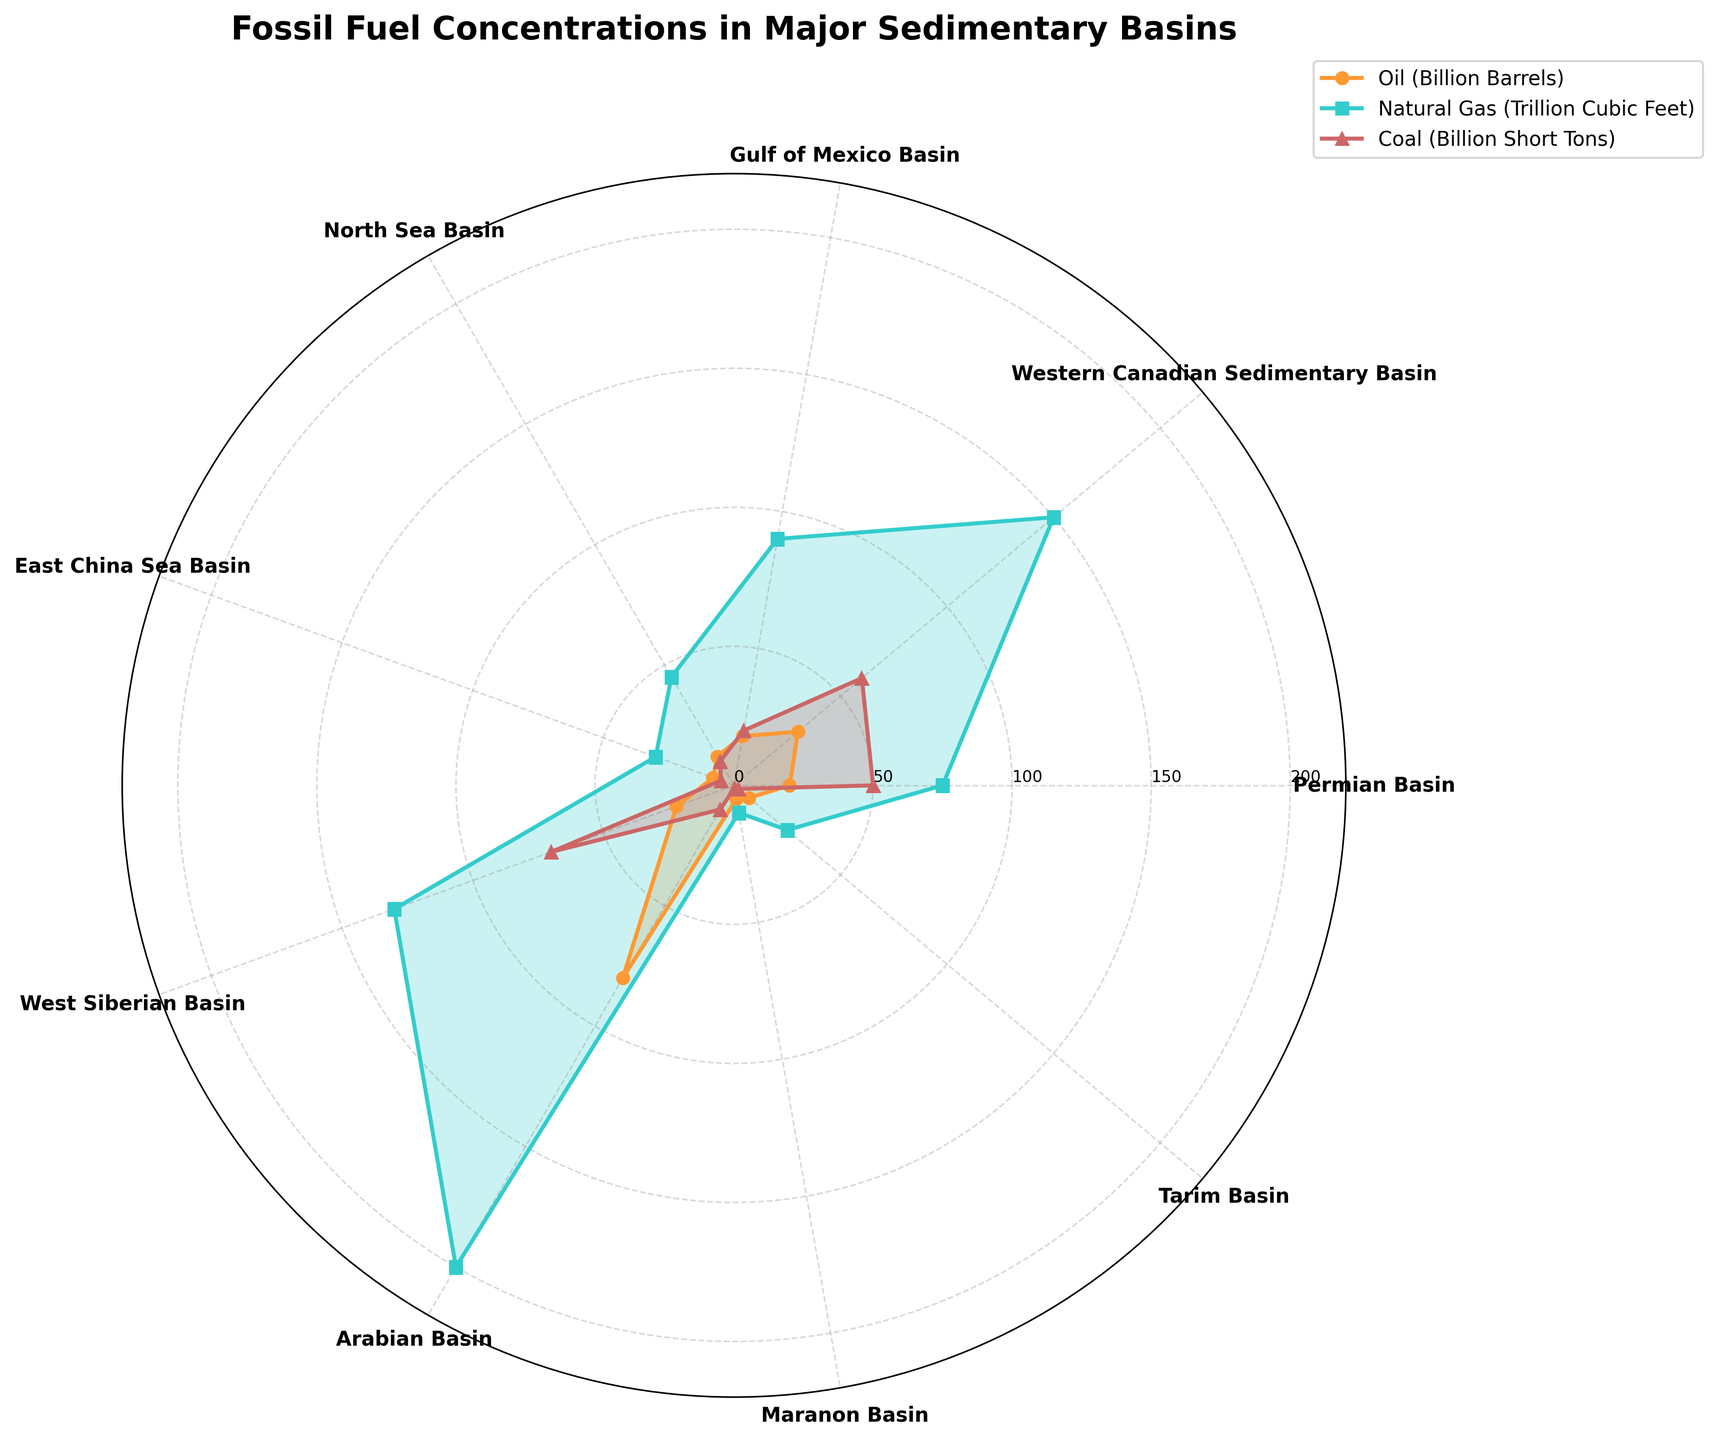What is the title of the polar chart? The title of the chart is prominently displayed at the top and reads "Fossil Fuel Concentrations in Major Sedimentary Basins".
Answer: Fossil Fuel Concentrations in Major Sedimentary Basins What are the labels for the three types of fossil fuels represented in the polar chart? The labels for the three types of fossil fuels can be found in the legend on the right side of the chart. They are "Oil (Billion Barrels)", "Natural Gas (Trillion Cubic Feet)", and "Coal (Billion Short Tons)".
Answer: Oil (Billion Barrels), Natural Gas (Trillion Cubic Feet), Coal (Billion Short Tons) Which sedimentary basin shows the highest concentration of natural gas? By finding the peak of the blue (Natural Gas) line on the chart, we can observe that the Arabian Basin has the highest concentration of natural gas, indicated by the highest point on the blue line.
Answer: Arabian Basin Of the basins listed, which two have the least concentration of coal, and how much coal do they contain collectively? The basins with the lowest concentration of coal are the Maranon Basin (1 Billion Short Ton) and the Tarim Basin (2 Billion Short Tons). Summing these values: 1 + 2 = 3 Billion Short Tons.
Answer: Maranon Basin and Tarim Basin; 3 Billion Short Tons Compare the concentrations of oil and coal in the Western Canadian Sedimentary Basin. Which is higher, and by what amount? To compare, we look at the heights of the orange (Oil) and red (Coal) lines for the Western Canadian Sedimentary Basin. Oil is at 30 Billion Barrels, and coal is at 60 Billion Short Tons. The difference is 60 - 30 = 30 units (in their respective units, but for this comparison, we use the same numerical value of 30).
Answer: Coal is higher by 30 units What is the total concentration of all three fossil fuels in the Permian Basin? By summing the values of the three fossil fuels in the Permian Basin: Oil (20 Billion Barrels) + Natural Gas (75 Trillion Cubic Feet) + Coal (50 Billion Short Tons), we get the total concentration. 20 + 75 + 50 = 145 units.
Answer: 145 units Which basin has the second lowest concentration of oil? Observing the orange (Oil) line for the basin with the second smallest peak, we find that the Tarim Basin has the second lowest concentration of oil, which is 7 Billion Barrels.
Answer: Tarim Basin How does the concentration of oil in the North Sea Basin compare to its concentration of natural gas? For the North Sea Basin, the orange (Oil) line is at 12 Billion Barrels, and the blue (Natural Gas) line is at 45 Trillion Cubic Feet. Natural Gas is higher: 45 - 12 = 33 units more.
Answer: Natural Gas is higher by 33 units What is the average concentration of coal across all basins? First, we sum the coal concentrations across all basins: 50 + 60 + 20 + 10 + 5 + 70 + 10 + 1 + 2 = 228. Then we divide by the number of basins, which is 9. So, 228 / 9 ≈ 25.33 Billion Short Tons.
Answer: Approximately 25.33 Billion Short Tons Which basin shows a higher concentration of oil compared to the West Siberian Basin? By comparing the orange (Oil) lines, we see that the Arabian Basin (80 Billion Barrels) has a higher concentration of oil than the West Siberian Basin (22 Billion Barrels).
Answer: Arabian Basin 